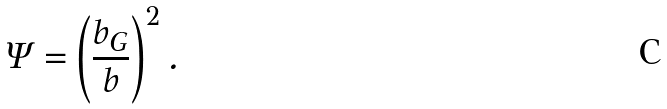<formula> <loc_0><loc_0><loc_500><loc_500>\Psi = \left ( \frac { b _ { G } } { b } \right ) ^ { 2 } .</formula> 